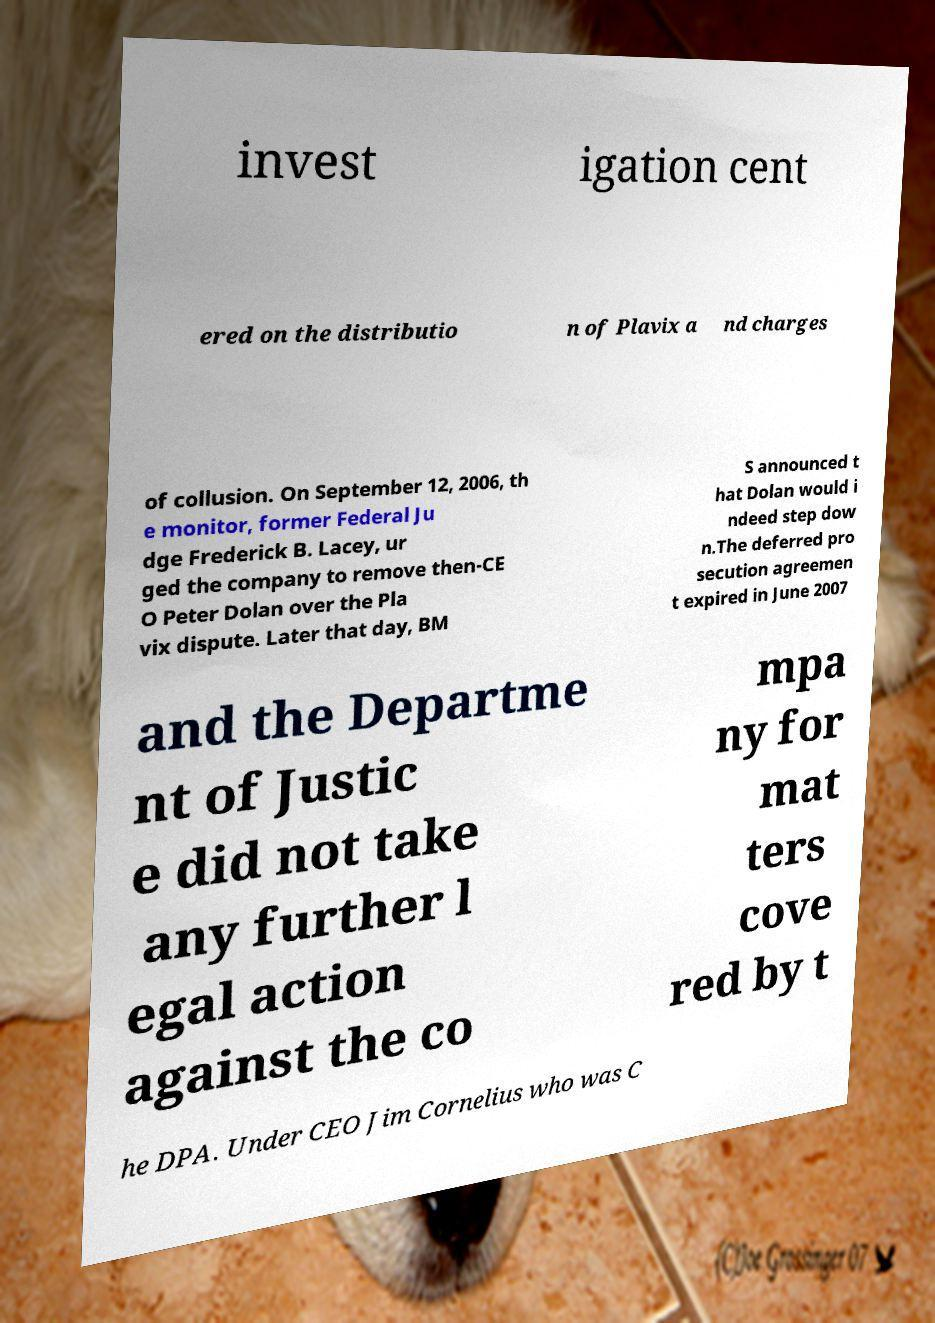For documentation purposes, I need the text within this image transcribed. Could you provide that? invest igation cent ered on the distributio n of Plavix a nd charges of collusion. On September 12, 2006, th e monitor, former Federal Ju dge Frederick B. Lacey, ur ged the company to remove then-CE O Peter Dolan over the Pla vix dispute. Later that day, BM S announced t hat Dolan would i ndeed step dow n.The deferred pro secution agreemen t expired in June 2007 and the Departme nt of Justic e did not take any further l egal action against the co mpa ny for mat ters cove red by t he DPA. Under CEO Jim Cornelius who was C 